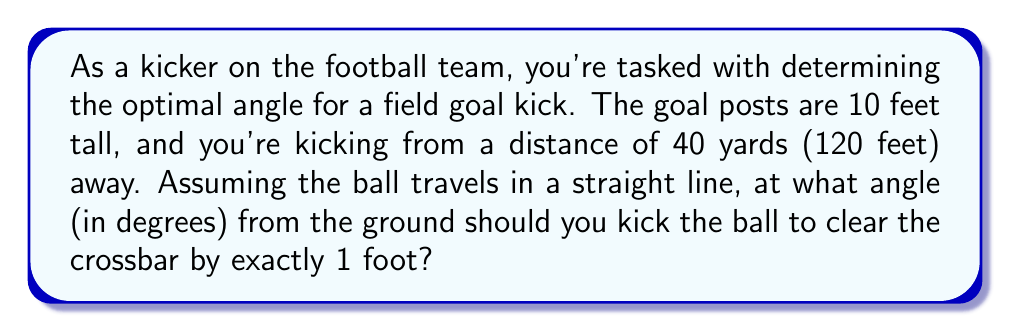Provide a solution to this math problem. Let's approach this step-by-step:

1) First, let's visualize the problem:

[asy]
import geometry;

unitsize(0.05cm);

pair A = (0,0);
pair B = (120,0);
pair C = (120,10);
pair D = (120,11);

draw(A--B--C--D);
draw(A--D,red);

label("Kicker", A, SW);
label("Crossbar", C, E);
label("1 ft", (120,10.5), E);
label("10 ft", (120,5), E);
label("120 ft", (60,0), S);
label("$\theta$", (5,5), NW);

dot("A",A,SW);
dot("B",B,SE);
dot("C",C,E);
dot("D",D,NE);
[/asy]

2) We can solve this using trigonometry. The angle we're looking for is the angle between the ground and the line from the kicker to the point 1 foot above the crossbar.

3) We can use the tangent function to find this angle. The tangent of an angle is the opposite side divided by the adjacent side.

4) In this case:
   - The opposite side is the height of the crossbar plus 1 foot: 11 feet
   - The adjacent side is the distance to the goal posts: 120 feet

5) Let $\theta$ be the angle we're looking for. Then:

   $$\tan(\theta) = \frac{11}{120}$$

6) To solve for $\theta$, we need to use the inverse tangent (arctan) function:

   $$\theta = \arctan(\frac{11}{120})$$

7) Using a calculator or computer:

   $$\theta \approx 5.2364^\circ$$

8) Rounding to two decimal places:

   $$\theta \approx 5.24^\circ$$
Answer: $5.24^\circ$ 